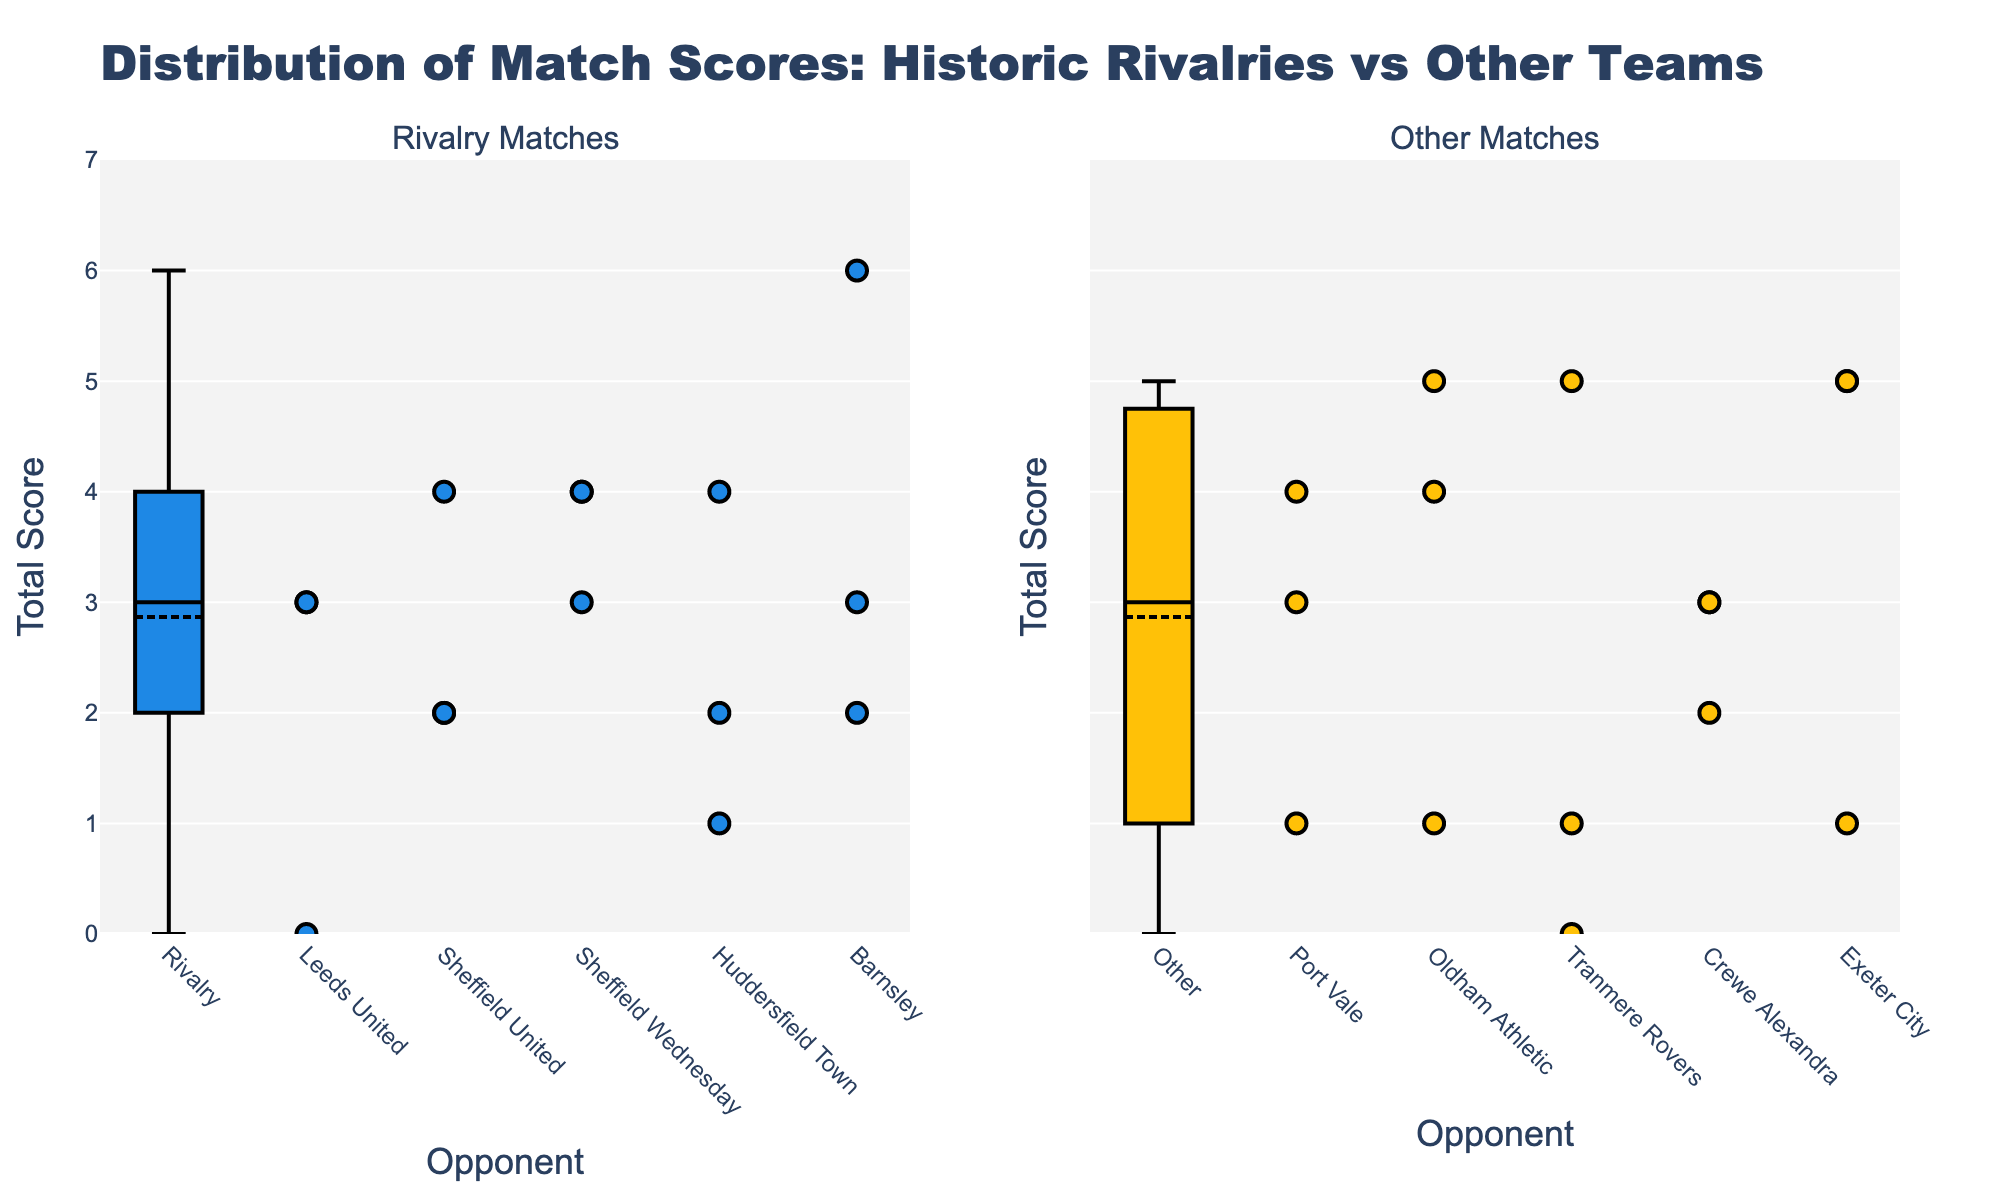what does the title of the figure indicate? The title indicates that the figure shows the distribution of match scores for Bradford City in historic rivalries compared to other teams.
Answer: Distribution of Match Scores: Historic Rivalries vs Other Teams How do the scores of rivalry matches compare with those of other matches? By assessing both the box plots and scatter points, you can see that the range of scores for rivalry matches tends to be wider with some higher and some lower scores, whereas the scores for other matches are more tightly clustered around central values.
Answer: Rivalry matches have a wider score range compared to other matches What is the median score for rivalry matches? The box plot for rivalry matches indicates the median score by the line inside the box. Observing this line, the median score for rivalry matches appears to be around 3.
Answer: 3 Which set of matches shows a greater score variability? Score variability is indicated by the range and the length of the whiskers in the box plot. Rivalry matches have longer whiskers, showing greater variability in scores.
Answer: Rivalry matches What is the highest score achieved in other matches? The maximum score can be determined from the top whisker or the highest scatter point in the box plot for other matches. The highest score appears to be 6.
Answer: 6 Which opponent has the lowest total score in rivalry matches? By looking at the scatter points for rivalry matches, we see that the lowest score is against Leeds United with a total score of 0.
Answer: Leeds United How does the average score of rivalry matches compare to other matches? To find the average, refer to the box mean mark in the box plot. The mean score for rivalry matches is higher compared to that of other matches, as indicated by the location of the diamond-shaped mean mark.
Answer: Rivalry matches have a higher average score Which match type has fewer extreme outliers? Outliers are represented by points outside the whiskers in box plots. The plot for other matches displays fewer outliers compared to rivalry matches.
Answer: Other matches Looking at the opponents, which match type has more scattered points away from the central box? The scatter points in rivalry matches are more spread out compared to the other matches, suggesting a greater range of scores.
Answer: Rivalry matches What can be inferred about the consistency of Bradford City’s performance against other teams compared to rivalry teams? Other teams show a more consistent performance with clustering around the central values and a smaller range of scores, while rivalry matches show a greater inconsistency with a wider range.
Answer: More consistent against other teams 